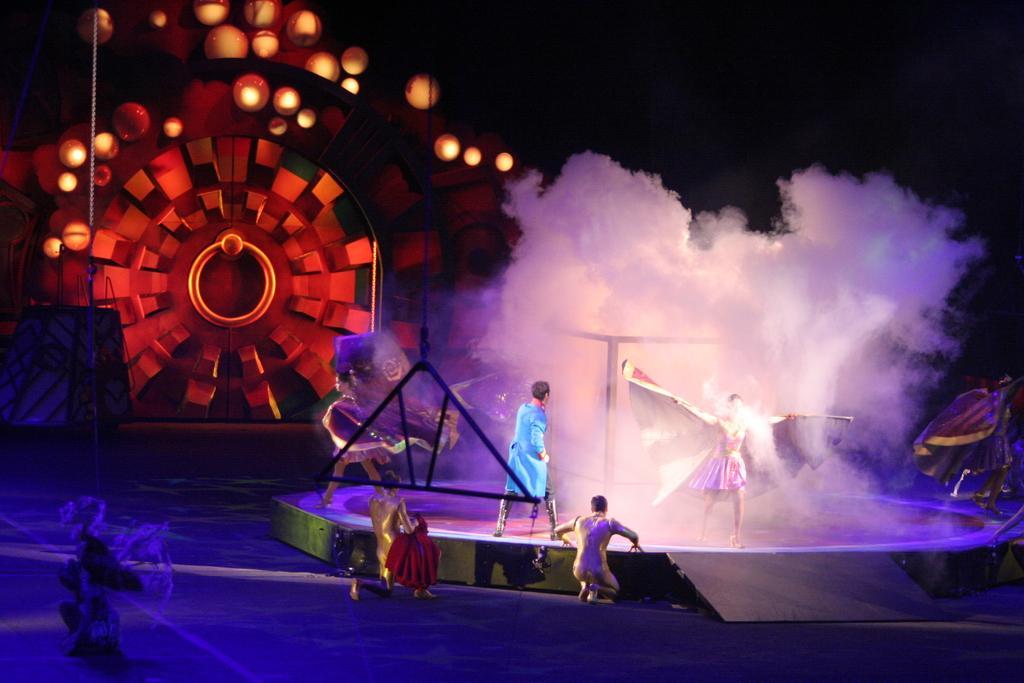How would you summarize this image in a sentence or two? In this image we can see these people are standing on the stage. Here we can also see white smoke, lights and some other objects on the stage. Here I can see are a chain, gate and some lights. The background of the image is dark. 